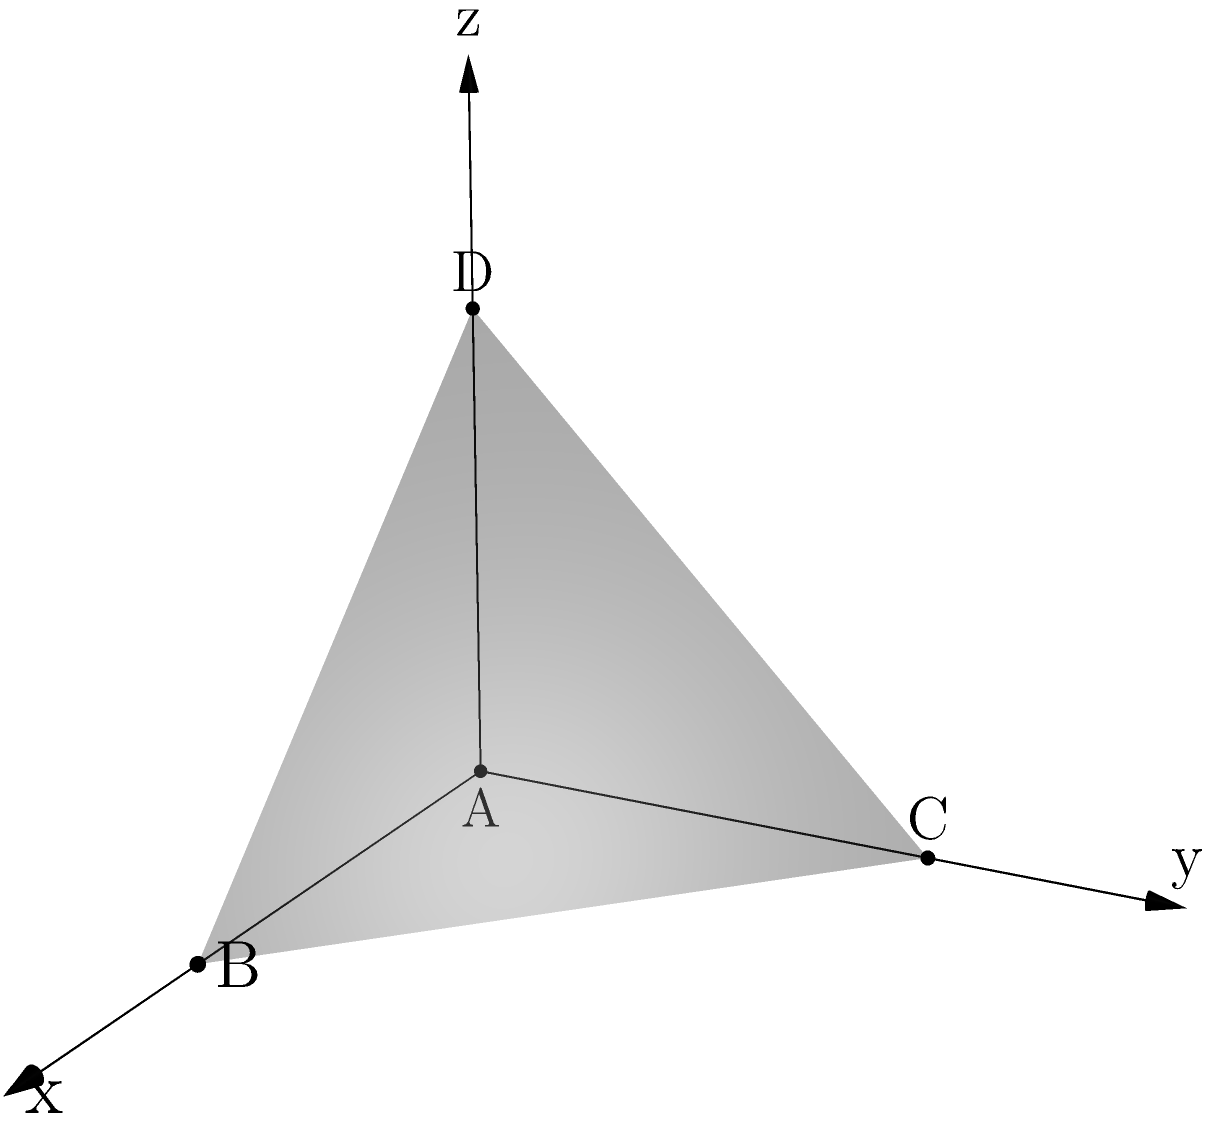As a decision-maker in the science and technology sector, you're exploring the implications of quantum mechanics on spatial geometry. Consider a tetrahedron ABCD in three-dimensional space with vertices A(0,0,0), B(2,0,0), C(0,2,0), and D(0,0,2). Calculate the volume of this tetrahedron using the given coordinates. To calculate the volume of a tetrahedron given the coordinates of its vertices, we can use the following steps:

1) The volume of a tetrahedron can be calculated using the determinant method:

   $$V = \frac{1}{6}\left|\det\begin{pmatrix}
   x_1 & y_1 & z_1 & 1 \\
   x_2 & y_2 & z_2 & 1 \\
   x_3 & y_3 & z_3 & 1 \\
   x_4 & y_4 & z_4 & 1
   \end{pmatrix}\right|$$

2) Substituting the given coordinates:

   $$V = \frac{1}{6}\left|\det\begin{pmatrix}
   0 & 0 & 0 & 1 \\
   2 & 0 & 0 & 1 \\
   0 & 2 & 0 & 1 \\
   0 & 0 & 2 & 1
   \end{pmatrix}\right|$$

3) Expanding the determinant:

   $$V = \frac{1}{6}[(0 \cdot 0 \cdot 2 \cdot 1) + (0 \cdot 0 \cdot 1 \cdot 2) + (0 \cdot 2 \cdot 0 \cdot 0) \\
   - (0 \cdot 0 \cdot 0 \cdot 1) - (0 \cdot 2 \cdot 2 \cdot 0) - (2 \cdot 0 \cdot 0 \cdot 1)]$$

4) Simplifying:

   $$V = \frac{1}{6}[0 + 0 + 0 - 0 - 0 - 0] + \frac{1}{6}[2 \cdot 2 \cdot 2]$$

5) Calculating the final result:

   $$V = \frac{1}{6} \cdot 8 = \frac{4}{3}$$

Therefore, the volume of the tetrahedron is $\frac{4}{3}$ cubic units.
Answer: $\frac{4}{3}$ cubic units 